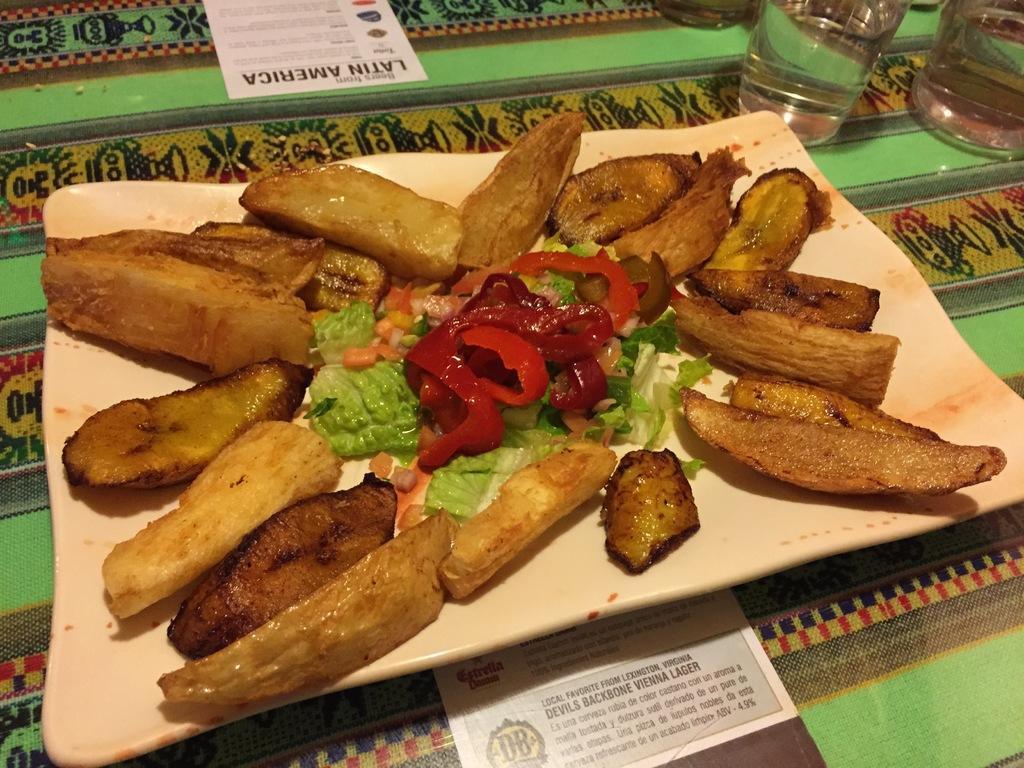Could you give a brief overview of what you see in this image? In this image we can see a plate containing food which is placed on the surface. In the background we can see some glasses and some papers with text placed on the surface. 